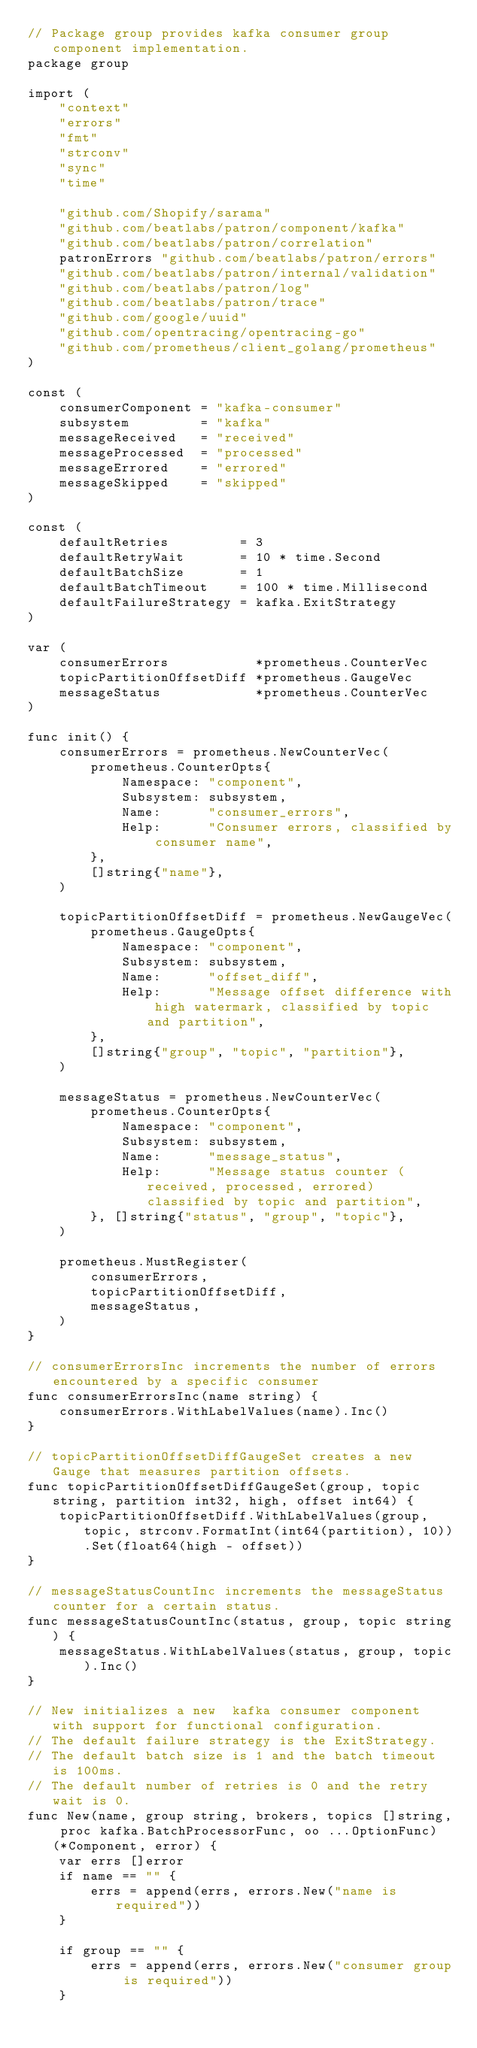<code> <loc_0><loc_0><loc_500><loc_500><_Go_>// Package group provides kafka consumer group component implementation.
package group

import (
	"context"
	"errors"
	"fmt"
	"strconv"
	"sync"
	"time"

	"github.com/Shopify/sarama"
	"github.com/beatlabs/patron/component/kafka"
	"github.com/beatlabs/patron/correlation"
	patronErrors "github.com/beatlabs/patron/errors"
	"github.com/beatlabs/patron/internal/validation"
	"github.com/beatlabs/patron/log"
	"github.com/beatlabs/patron/trace"
	"github.com/google/uuid"
	"github.com/opentracing/opentracing-go"
	"github.com/prometheus/client_golang/prometheus"
)

const (
	consumerComponent = "kafka-consumer"
	subsystem         = "kafka"
	messageReceived   = "received"
	messageProcessed  = "processed"
	messageErrored    = "errored"
	messageSkipped    = "skipped"
)

const (
	defaultRetries         = 3
	defaultRetryWait       = 10 * time.Second
	defaultBatchSize       = 1
	defaultBatchTimeout    = 100 * time.Millisecond
	defaultFailureStrategy = kafka.ExitStrategy
)

var (
	consumerErrors           *prometheus.CounterVec
	topicPartitionOffsetDiff *prometheus.GaugeVec
	messageStatus            *prometheus.CounterVec
)

func init() {
	consumerErrors = prometheus.NewCounterVec(
		prometheus.CounterOpts{
			Namespace: "component",
			Subsystem: subsystem,
			Name:      "consumer_errors",
			Help:      "Consumer errors, classified by consumer name",
		},
		[]string{"name"},
	)

	topicPartitionOffsetDiff = prometheus.NewGaugeVec(
		prometheus.GaugeOpts{
			Namespace: "component",
			Subsystem: subsystem,
			Name:      "offset_diff",
			Help:      "Message offset difference with high watermark, classified by topic and partition",
		},
		[]string{"group", "topic", "partition"},
	)

	messageStatus = prometheus.NewCounterVec(
		prometheus.CounterOpts{
			Namespace: "component",
			Subsystem: subsystem,
			Name:      "message_status",
			Help:      "Message status counter (received, processed, errored) classified by topic and partition",
		}, []string{"status", "group", "topic"},
	)

	prometheus.MustRegister(
		consumerErrors,
		topicPartitionOffsetDiff,
		messageStatus,
	)
}

// consumerErrorsInc increments the number of errors encountered by a specific consumer
func consumerErrorsInc(name string) {
	consumerErrors.WithLabelValues(name).Inc()
}

// topicPartitionOffsetDiffGaugeSet creates a new Gauge that measures partition offsets.
func topicPartitionOffsetDiffGaugeSet(group, topic string, partition int32, high, offset int64) {
	topicPartitionOffsetDiff.WithLabelValues(group, topic, strconv.FormatInt(int64(partition), 10)).Set(float64(high - offset))
}

// messageStatusCountInc increments the messageStatus counter for a certain status.
func messageStatusCountInc(status, group, topic string) {
	messageStatus.WithLabelValues(status, group, topic).Inc()
}

// New initializes a new  kafka consumer component with support for functional configuration.
// The default failure strategy is the ExitStrategy.
// The default batch size is 1 and the batch timeout is 100ms.
// The default number of retries is 0 and the retry wait is 0.
func New(name, group string, brokers, topics []string, proc kafka.BatchProcessorFunc, oo ...OptionFunc) (*Component, error) {
	var errs []error
	if name == "" {
		errs = append(errs, errors.New("name is required"))
	}

	if group == "" {
		errs = append(errs, errors.New("consumer group is required"))
	}
</code> 